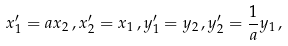<formula> <loc_0><loc_0><loc_500><loc_500>x _ { 1 } ^ { \prime } = a x _ { 2 } \, , x _ { 2 } ^ { \prime } = x _ { 1 } \, , y _ { 1 } ^ { \prime } = y _ { 2 } \, , y _ { 2 } ^ { \prime } = \frac { 1 } { a } y _ { 1 } \, ,</formula> 